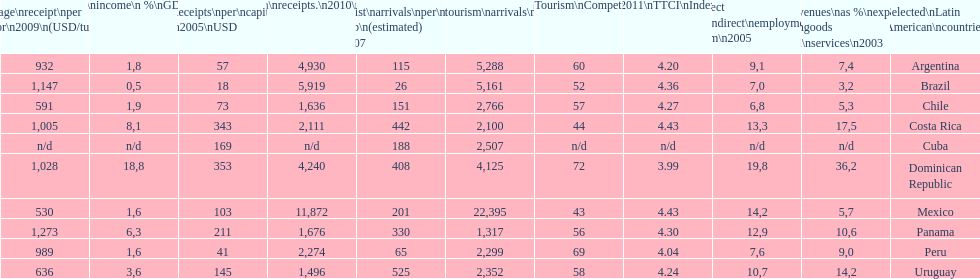What country had the most receipts per capita in 2005? Dominican Republic. 